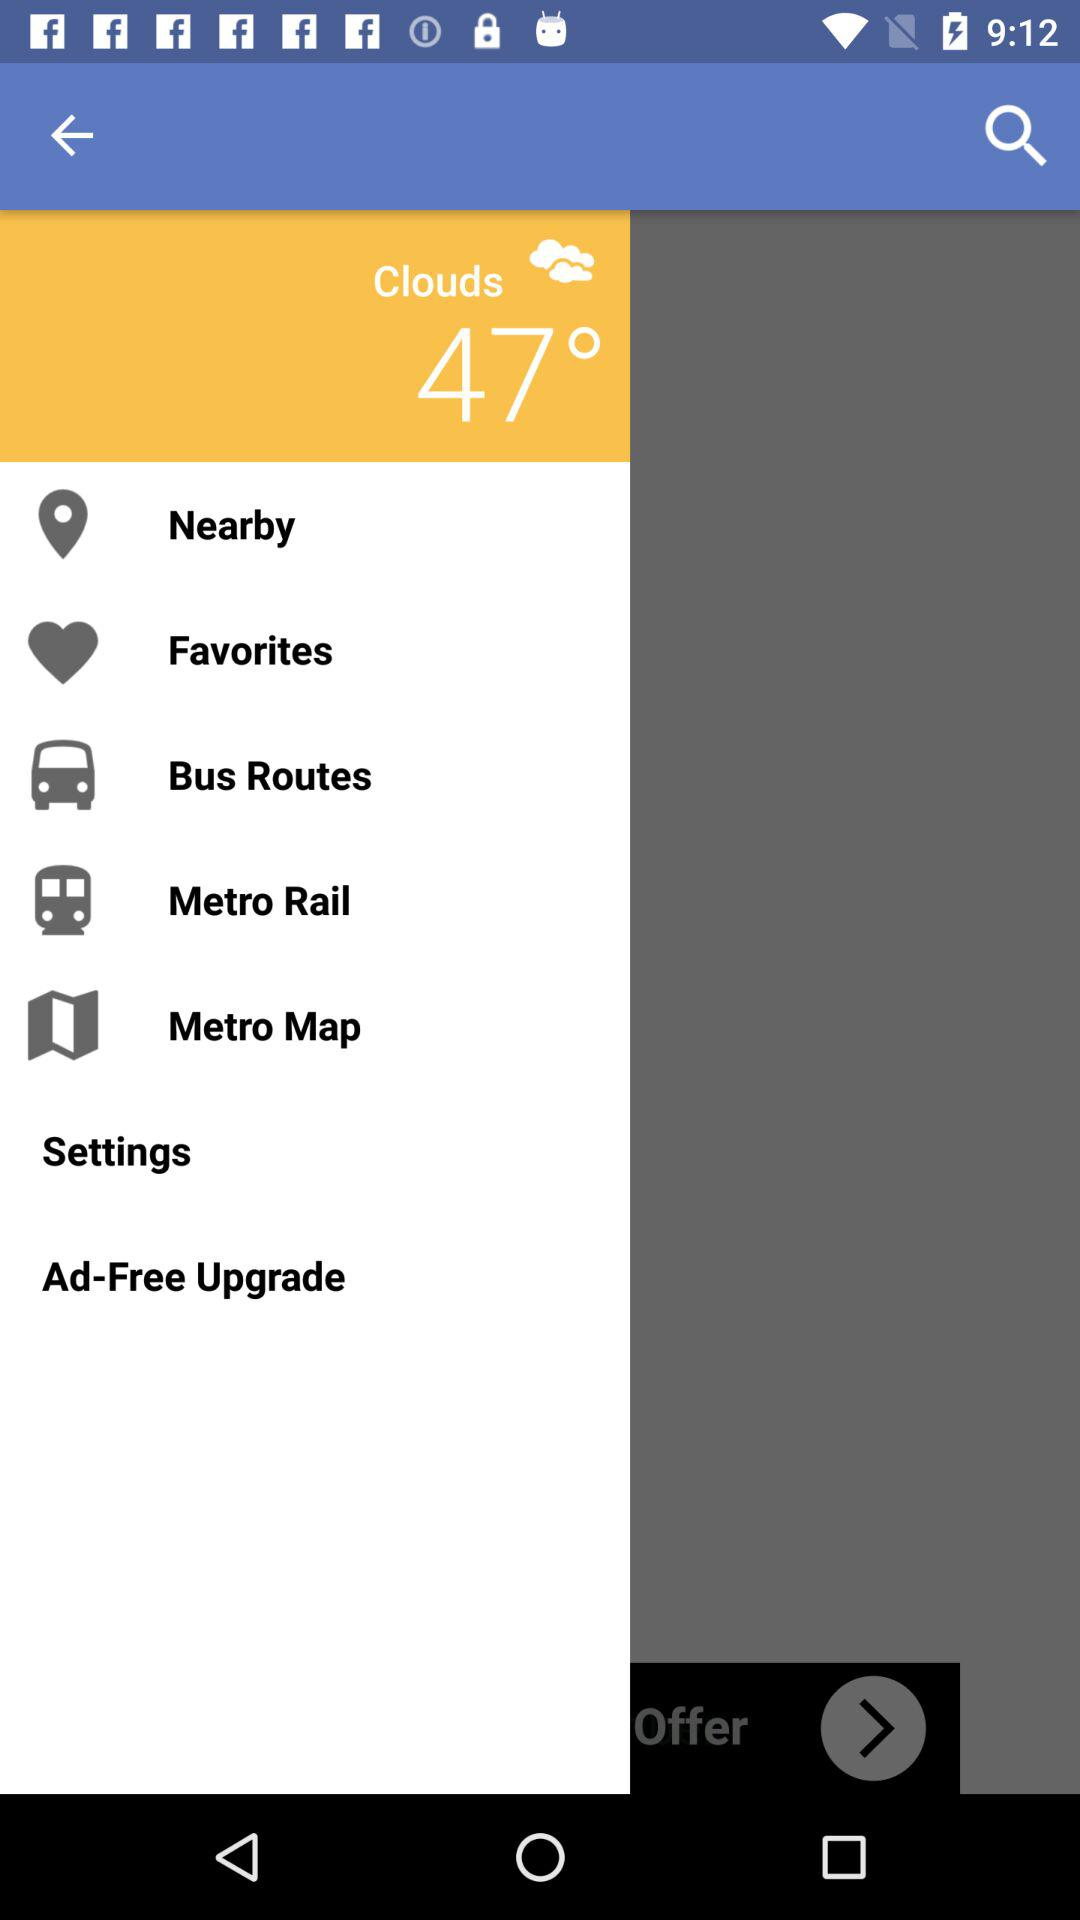What is the weather forecast? The weather is cloudy. 